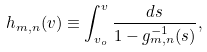<formula> <loc_0><loc_0><loc_500><loc_500>h _ { m , n } ( v ) \equiv \int _ { v _ { o } } ^ { v } \frac { d s } { 1 - g _ { m , n } ^ { - 1 } ( s ) } ,</formula> 